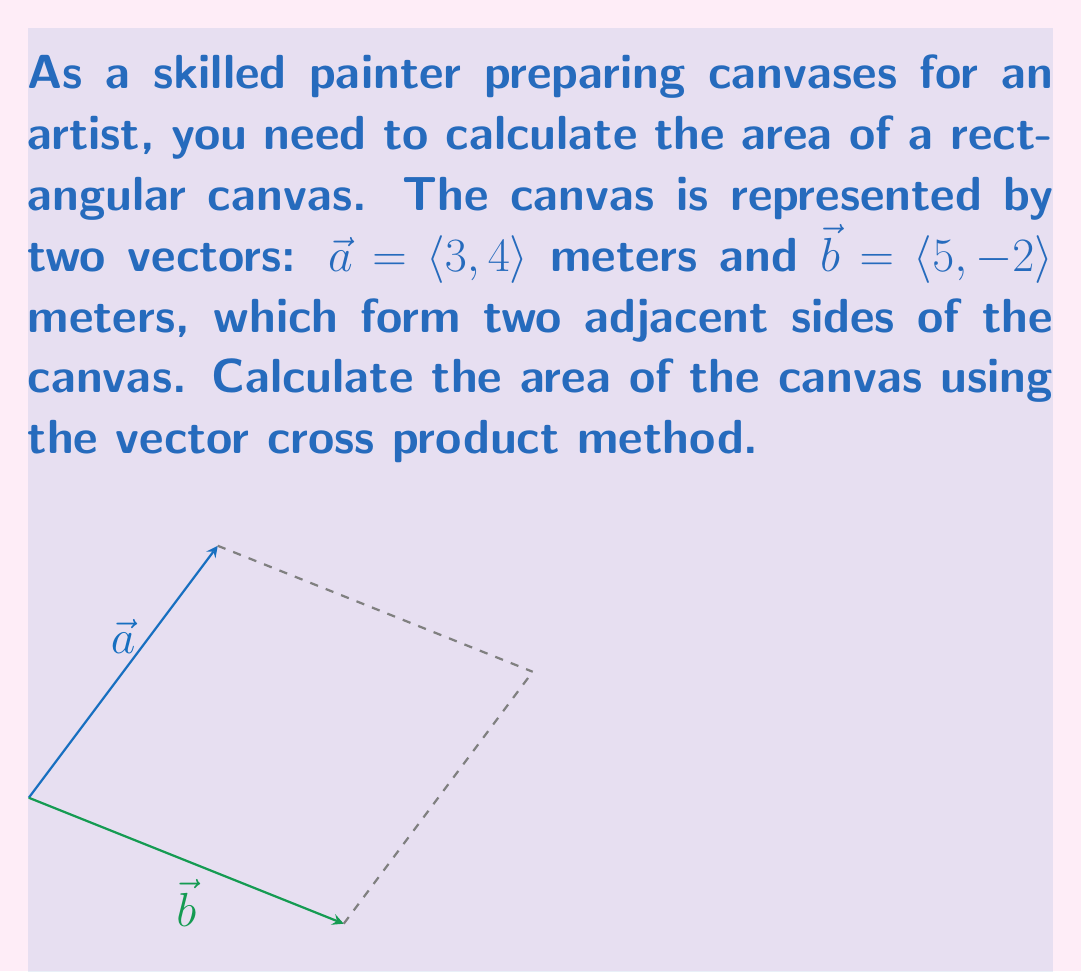Show me your answer to this math problem. To calculate the area of the canvas using vector cross product, we'll follow these steps:

1) The area of a parallelogram (which our canvas forms) is equal to the magnitude of the cross product of two adjacent sides.

2) For 2D vectors $\vec{a} = \langle a_1, a_2 \rangle$ and $\vec{b} = \langle b_1, b_2 \rangle$, the magnitude of their cross product is given by:

   $$|\vec{a} \times \vec{b}| = |a_1b_2 - a_2b_1|$$

3) Substituting our values:
   $\vec{a} = \langle 3, 4 \rangle$ and $\vec{b} = \langle 5, -2 \rangle$

4) Calculate:
   $$|\vec{a} \times \vec{b}| = |(3)(-2) - (4)(5)|$$
   $$= |-6 - 20|$$
   $$= |-26|$$
   $$= 26$$

5) The result is in square meters, as we're multiplying length by width.

Therefore, the area of the canvas is 26 square meters.
Answer: 26 m² 